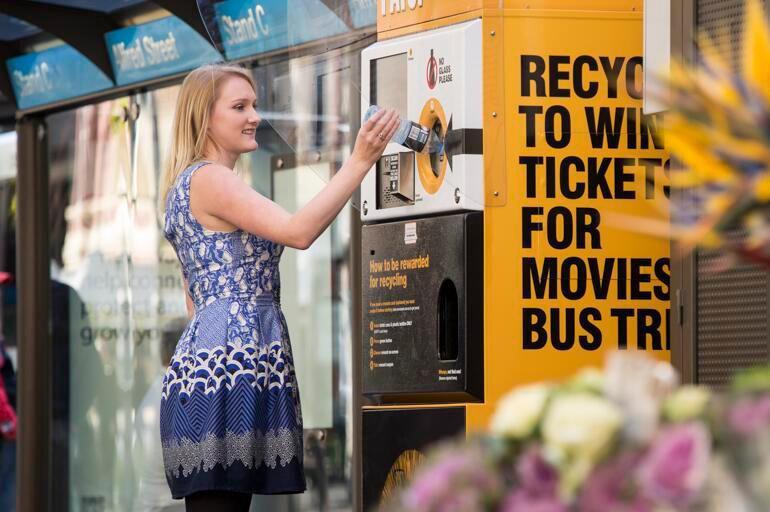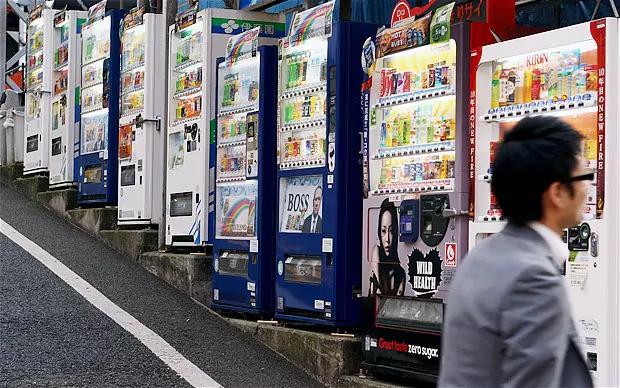The first image is the image on the left, the second image is the image on the right. Assess this claim about the two images: "there are no humans in front of the vending machine". Correct or not? Answer yes or no. No. The first image is the image on the left, the second image is the image on the right. For the images displayed, is the sentence "In one of the pictures of the pair, a red vending machine stands between a white machine and a black machine." factually correct? Answer yes or no. No. 